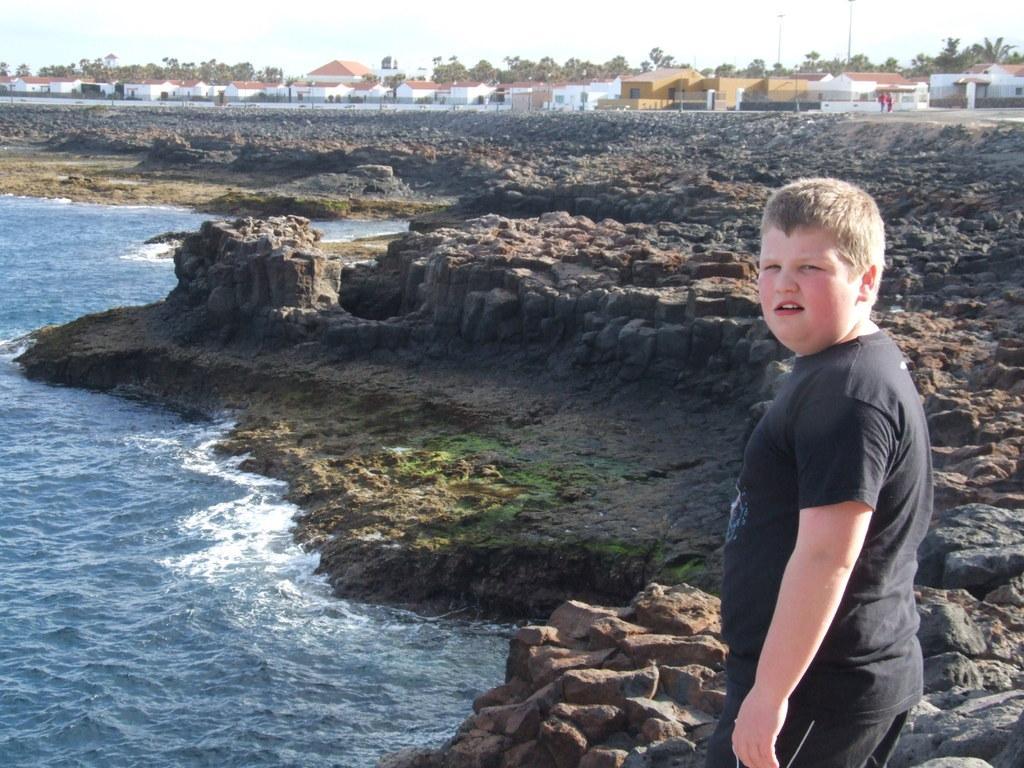In one or two sentences, can you explain what this image depicts? In this picture we can see a boy standing, water, rocks, trees, houses, poles and in the background we can see the sky. 